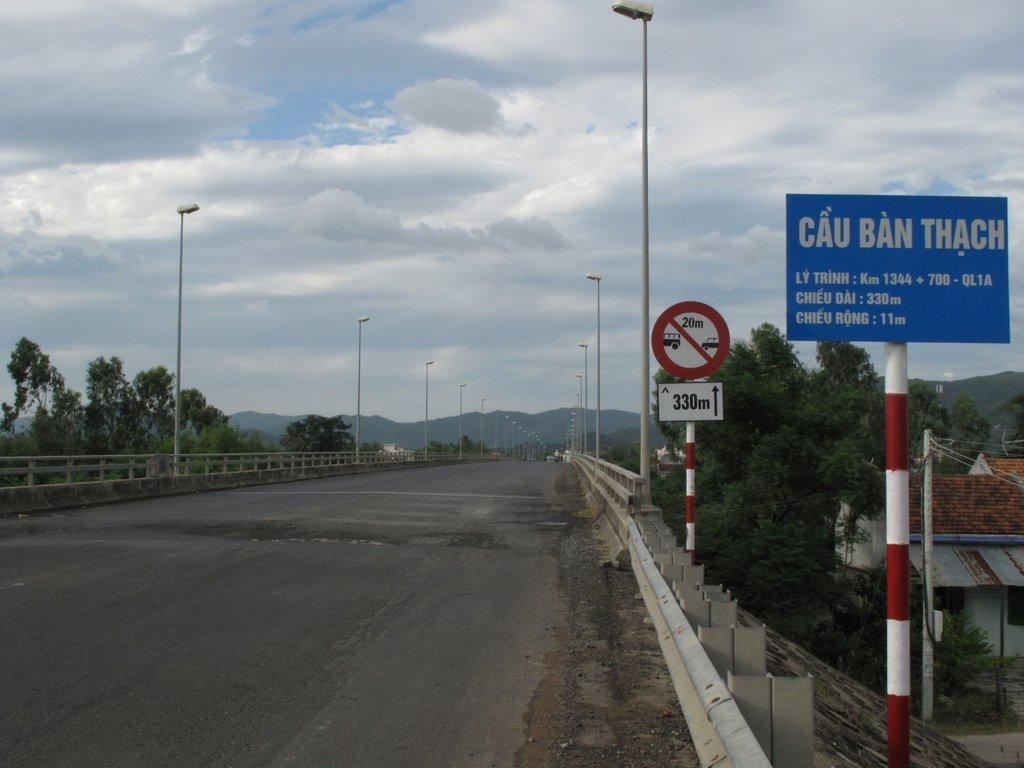<image>
Describe the image concisely. A blue road sign on the right that says Cau Ban Thach. 